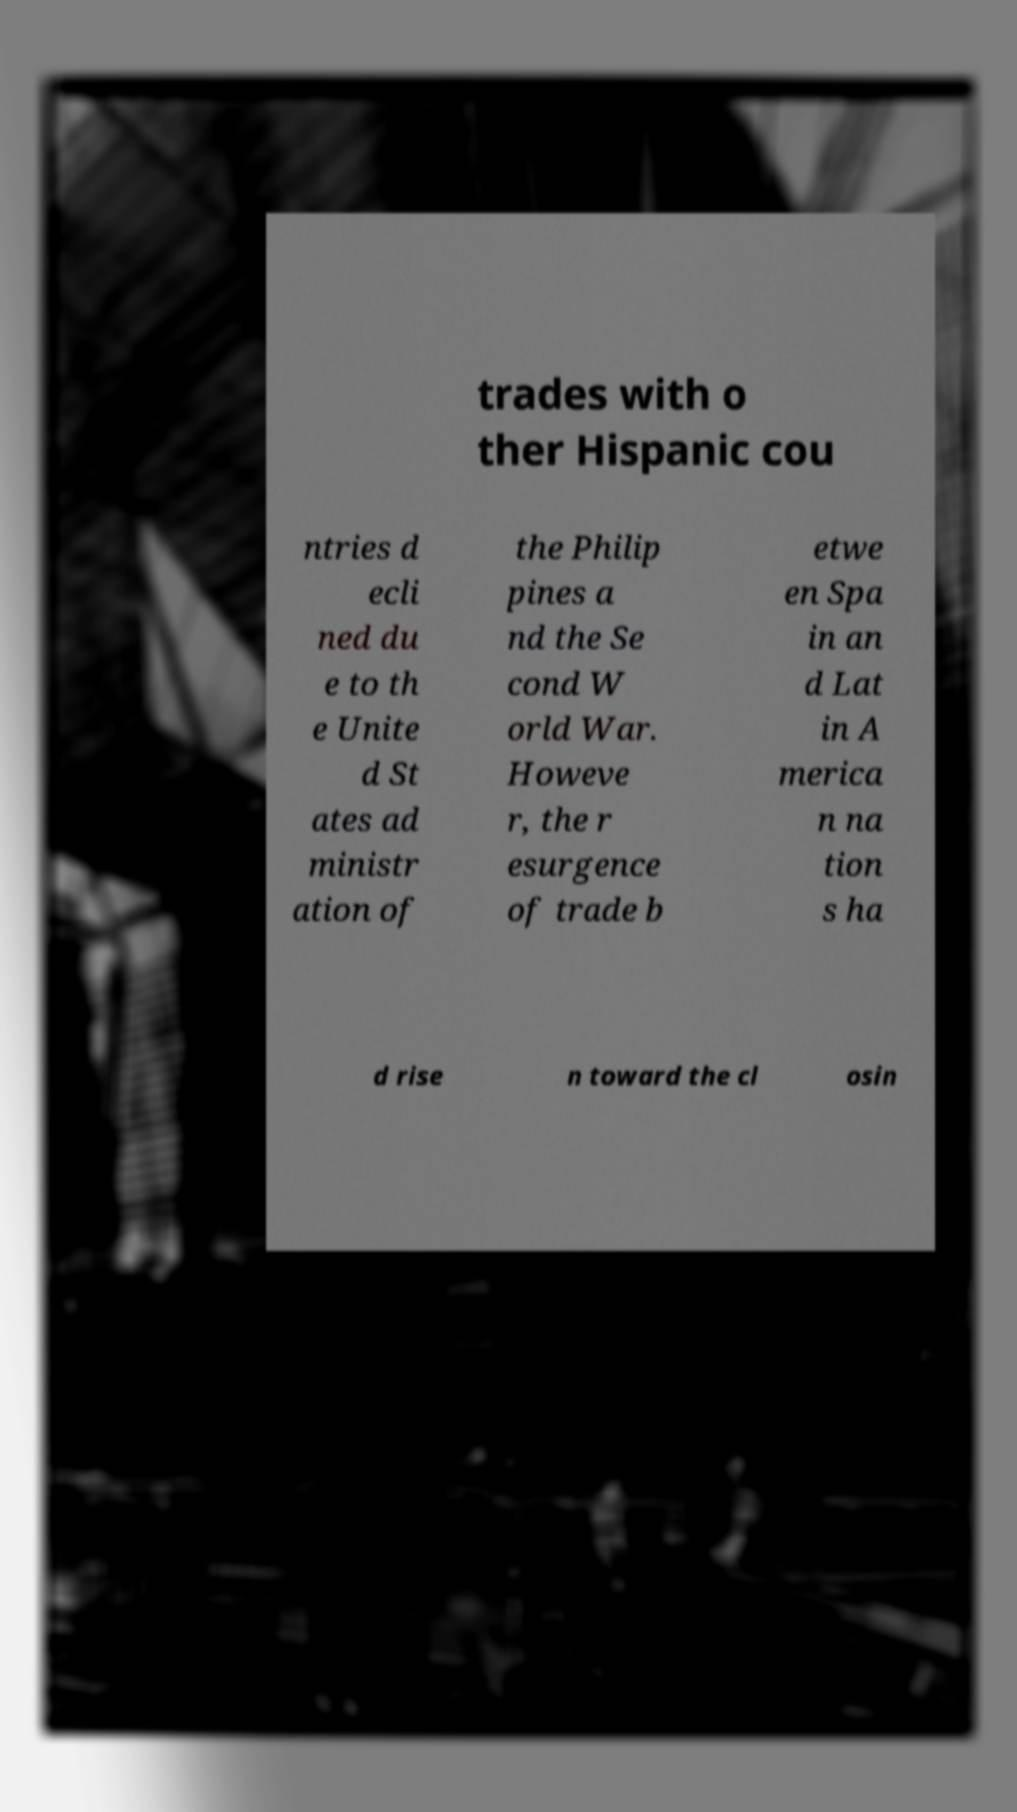Can you read and provide the text displayed in the image?This photo seems to have some interesting text. Can you extract and type it out for me? trades with o ther Hispanic cou ntries d ecli ned du e to th e Unite d St ates ad ministr ation of the Philip pines a nd the Se cond W orld War. Howeve r, the r esurgence of trade b etwe en Spa in an d Lat in A merica n na tion s ha d rise n toward the cl osin 